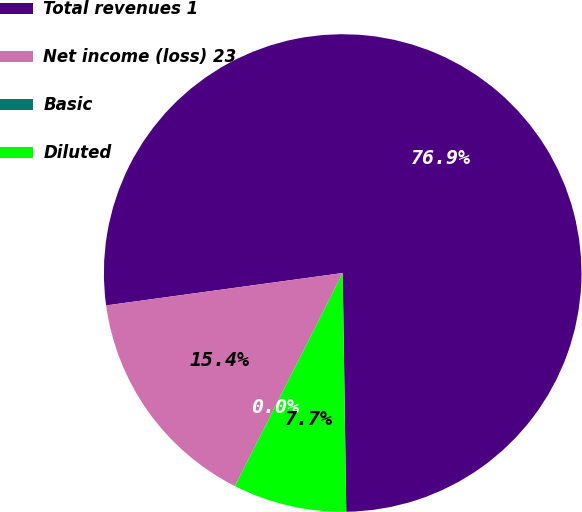<chart> <loc_0><loc_0><loc_500><loc_500><pie_chart><fcel>Total revenues 1<fcel>Net income (loss) 23<fcel>Basic<fcel>Diluted<nl><fcel>76.92%<fcel>15.38%<fcel>0.0%<fcel>7.69%<nl></chart> 